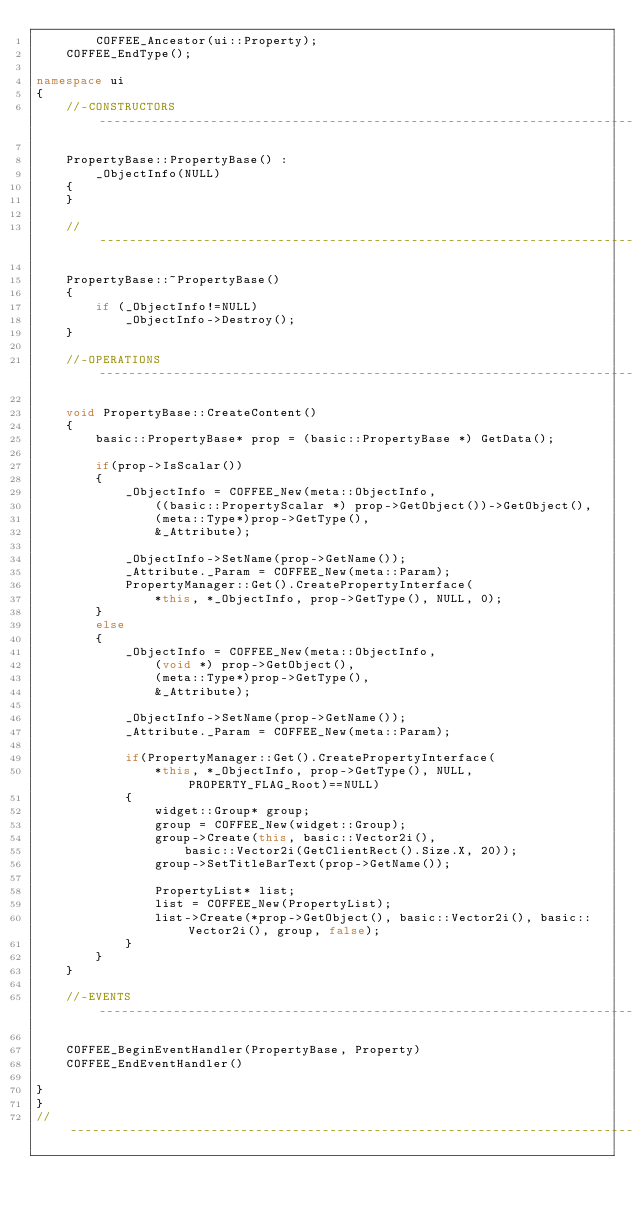Convert code to text. <code><loc_0><loc_0><loc_500><loc_500><_C++_>        COFFEE_Ancestor(ui::Property);
    COFFEE_EndType();

namespace ui
{
    //-CONSTRUCTORS-------------------------------------------------------------------------------//

    PropertyBase::PropertyBase() :
        _ObjectInfo(NULL)
    {
    }

    //--------------------------------------------------------------------------------------------//

    PropertyBase::~PropertyBase()
    {
        if (_ObjectInfo!=NULL)
            _ObjectInfo->Destroy();
    }

    //-OPERATIONS---------------------------------------------------------------------------------//

    void PropertyBase::CreateContent()
    {
        basic::PropertyBase* prop = (basic::PropertyBase *) GetData();

        if(prop->IsScalar())
        {
            _ObjectInfo = COFFEE_New(meta::ObjectInfo, 
                ((basic::PropertyScalar *) prop->GetObject())->GetObject(),
                (meta::Type*)prop->GetType(),
                &_Attribute);

            _ObjectInfo->SetName(prop->GetName());
            _Attribute._Param = COFFEE_New(meta::Param);
            PropertyManager::Get().CreatePropertyInterface(
                *this, *_ObjectInfo, prop->GetType(), NULL, 0);
        }
        else
        {
            _ObjectInfo = COFFEE_New(meta::ObjectInfo, 
                (void *) prop->GetObject(),
                (meta::Type*)prop->GetType(),
                &_Attribute);

            _ObjectInfo->SetName(prop->GetName());
            _Attribute._Param = COFFEE_New(meta::Param);

            if(PropertyManager::Get().CreatePropertyInterface(
                *this, *_ObjectInfo, prop->GetType(), NULL, PROPERTY_FLAG_Root)==NULL)
            {
                widget::Group* group;
                group = COFFEE_New(widget::Group);
                group->Create(this, basic::Vector2i(),
                    basic::Vector2i(GetClientRect().Size.X, 20));
                group->SetTitleBarText(prop->GetName());
                
                PropertyList* list;
                list = COFFEE_New(PropertyList);
                list->Create(*prop->GetObject(), basic::Vector2i(), basic::Vector2i(), group, false);
            }
        }
    }

    //-EVENTS-------------------------------------------------------------------------------------//

    COFFEE_BeginEventHandler(PropertyBase, Property)
    COFFEE_EndEventHandler()

}
}
//------------------------------------------------------------------------------------------------//
</code> 